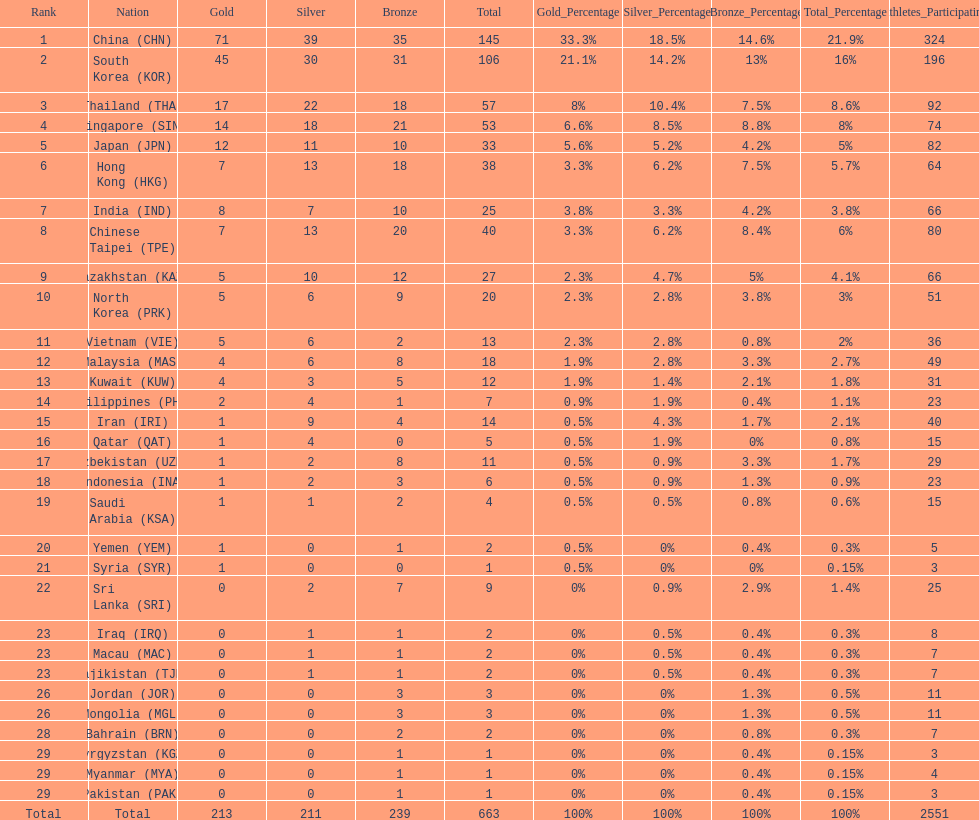What were the number of medals iran earned? 14. 